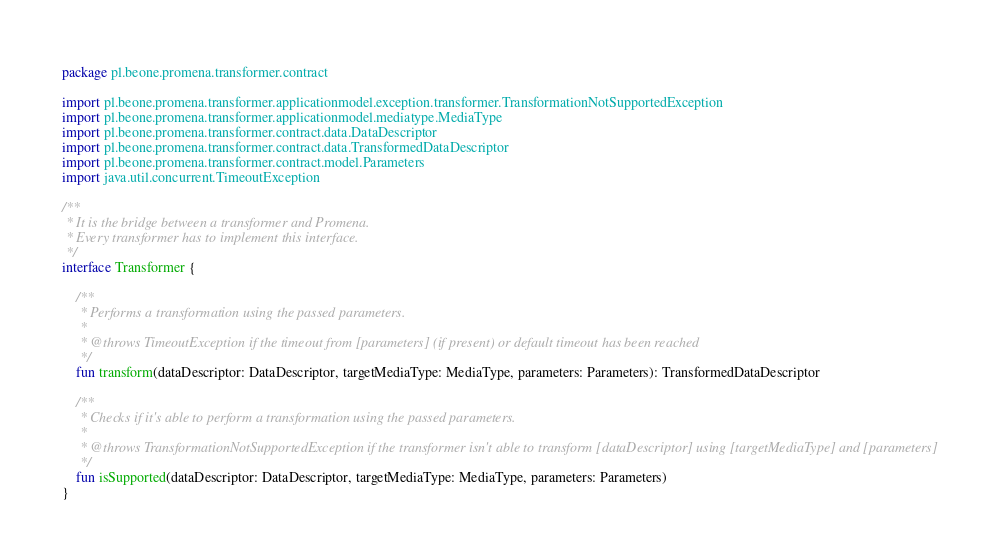Convert code to text. <code><loc_0><loc_0><loc_500><loc_500><_Kotlin_>package pl.beone.promena.transformer.contract

import pl.beone.promena.transformer.applicationmodel.exception.transformer.TransformationNotSupportedException
import pl.beone.promena.transformer.applicationmodel.mediatype.MediaType
import pl.beone.promena.transformer.contract.data.DataDescriptor
import pl.beone.promena.transformer.contract.data.TransformedDataDescriptor
import pl.beone.promena.transformer.contract.model.Parameters
import java.util.concurrent.TimeoutException

/**
 * It is the bridge between a transformer and Promena.
 * Every transformer has to implement this interface.
 */
interface Transformer {

    /**
     * Performs a transformation using the passed parameters.
     *
     * @throws TimeoutException if the timeout from [parameters] (if present) or default timeout has been reached
     */
    fun transform(dataDescriptor: DataDescriptor, targetMediaType: MediaType, parameters: Parameters): TransformedDataDescriptor

    /**
     * Checks if it's able to perform a transformation using the passed parameters.
     *
     * @throws TransformationNotSupportedException if the transformer isn't able to transform [dataDescriptor] using [targetMediaType] and [parameters]
     */
    fun isSupported(dataDescriptor: DataDescriptor, targetMediaType: MediaType, parameters: Parameters)
}</code> 